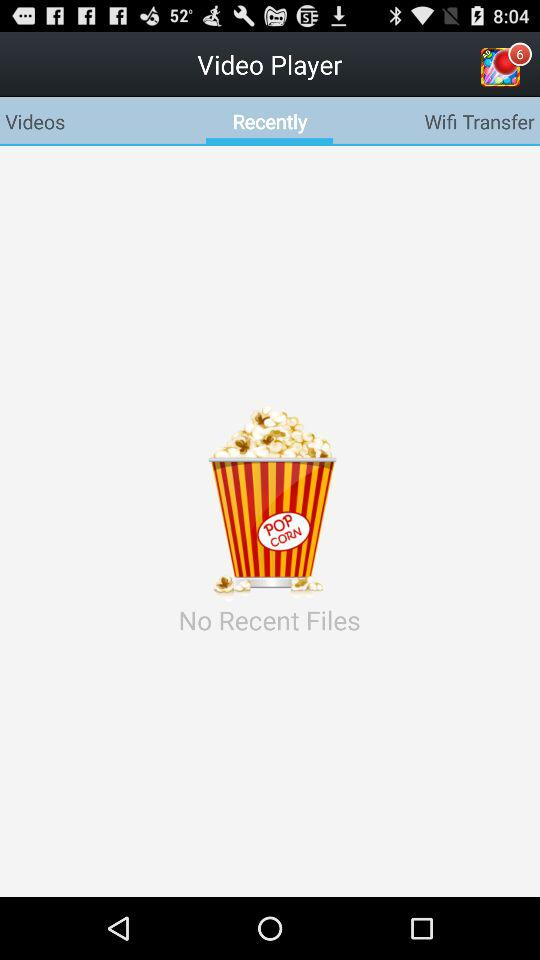Which tab am I using? You are using the "Recently" tab. 